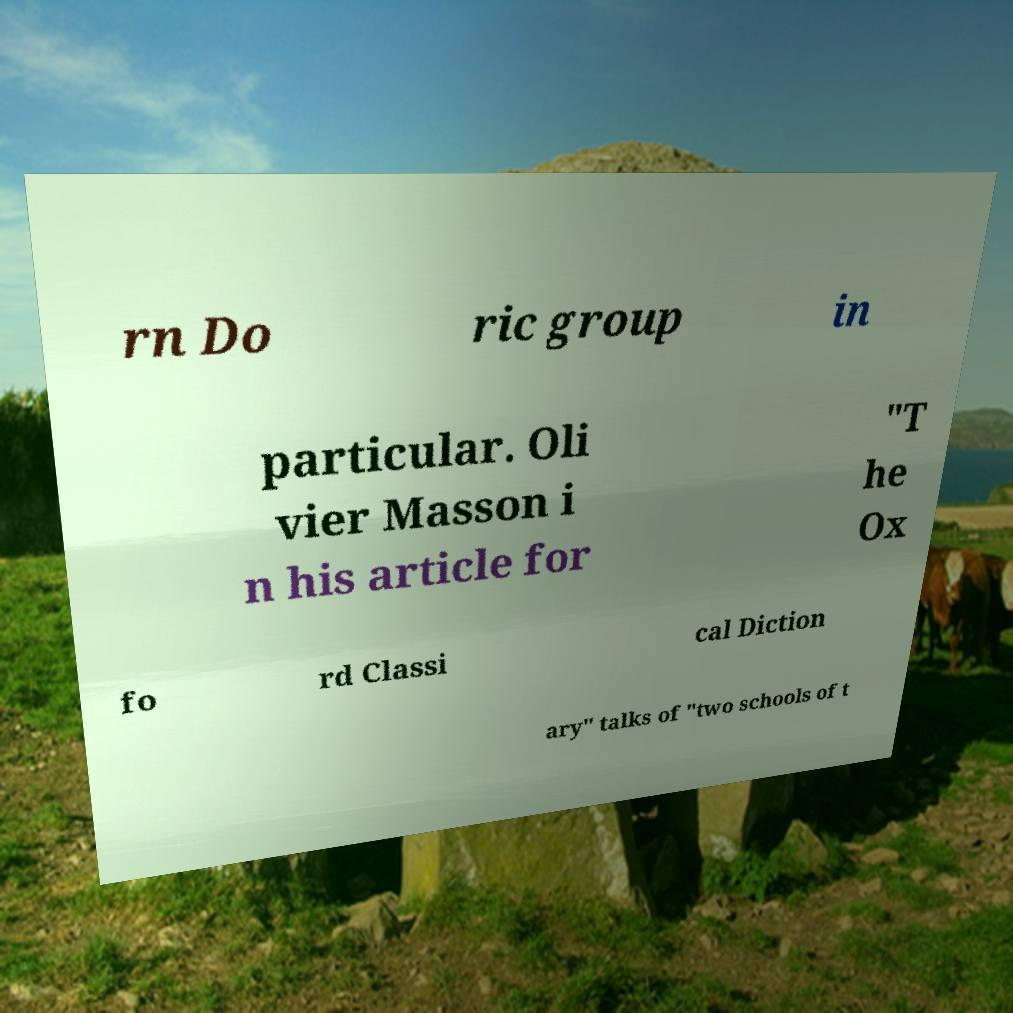Can you accurately transcribe the text from the provided image for me? rn Do ric group in particular. Oli vier Masson i n his article for "T he Ox fo rd Classi cal Diction ary" talks of "two schools of t 